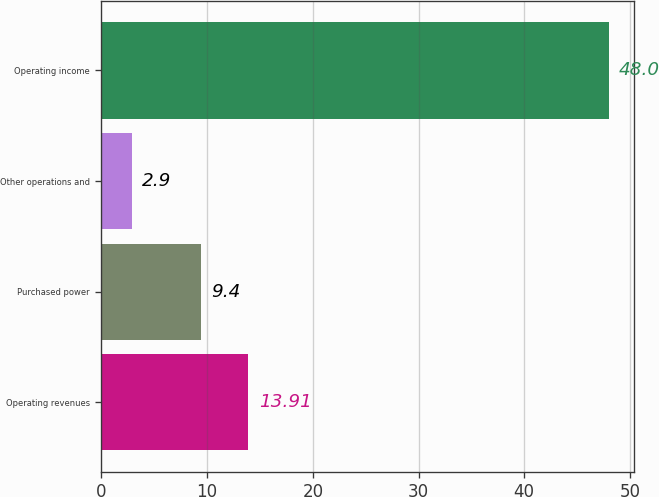<chart> <loc_0><loc_0><loc_500><loc_500><bar_chart><fcel>Operating revenues<fcel>Purchased power<fcel>Other operations and<fcel>Operating income<nl><fcel>13.91<fcel>9.4<fcel>2.9<fcel>48<nl></chart> 